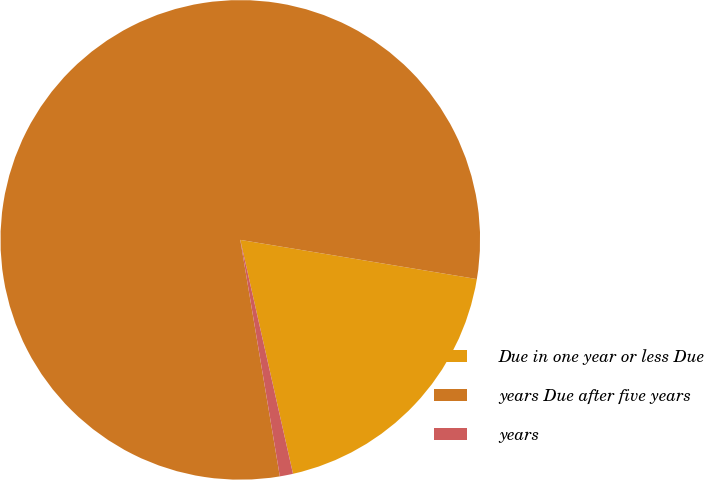Convert chart to OTSL. <chart><loc_0><loc_0><loc_500><loc_500><pie_chart><fcel>Due in one year or less Due<fcel>years Due after five years<fcel>years<nl><fcel>18.86%<fcel>80.25%<fcel>0.89%<nl></chart> 